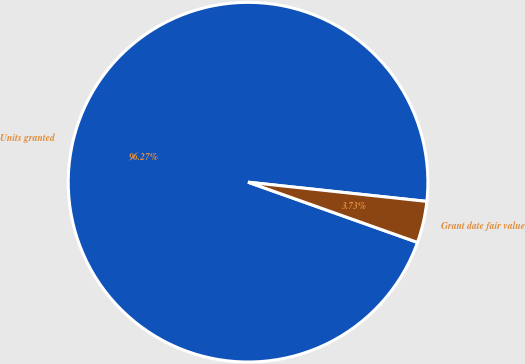Convert chart. <chart><loc_0><loc_0><loc_500><loc_500><pie_chart><fcel>Units granted<fcel>Grant date fair value<nl><fcel>96.27%<fcel>3.73%<nl></chart> 